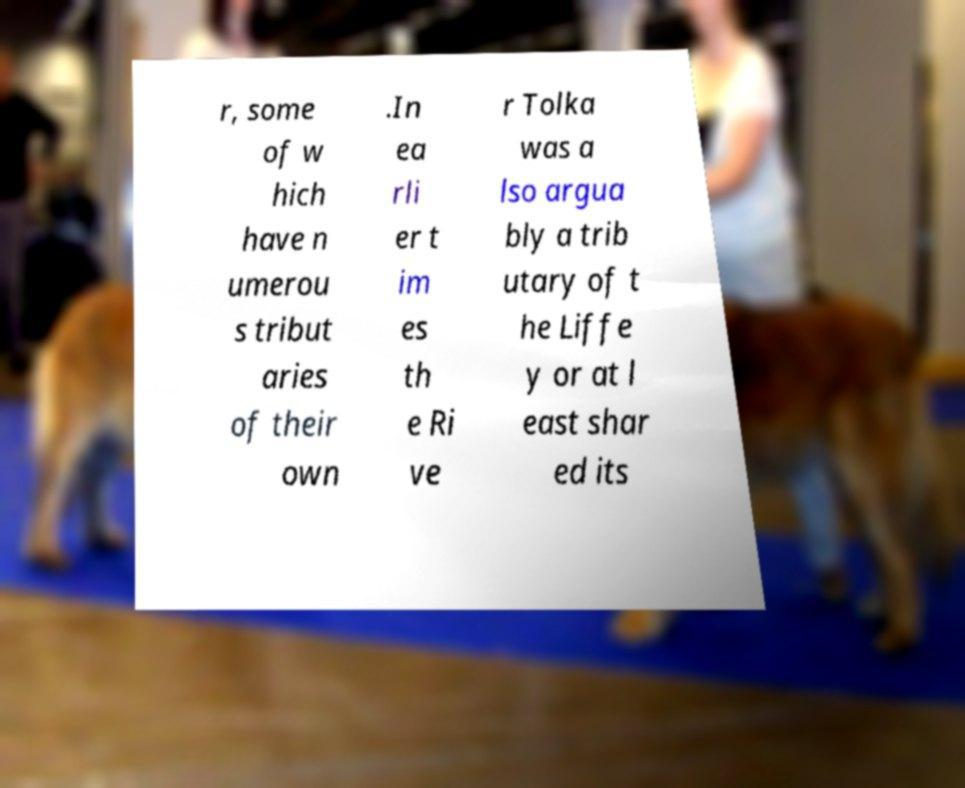Please identify and transcribe the text found in this image. r, some of w hich have n umerou s tribut aries of their own .In ea rli er t im es th e Ri ve r Tolka was a lso argua bly a trib utary of t he Liffe y or at l east shar ed its 